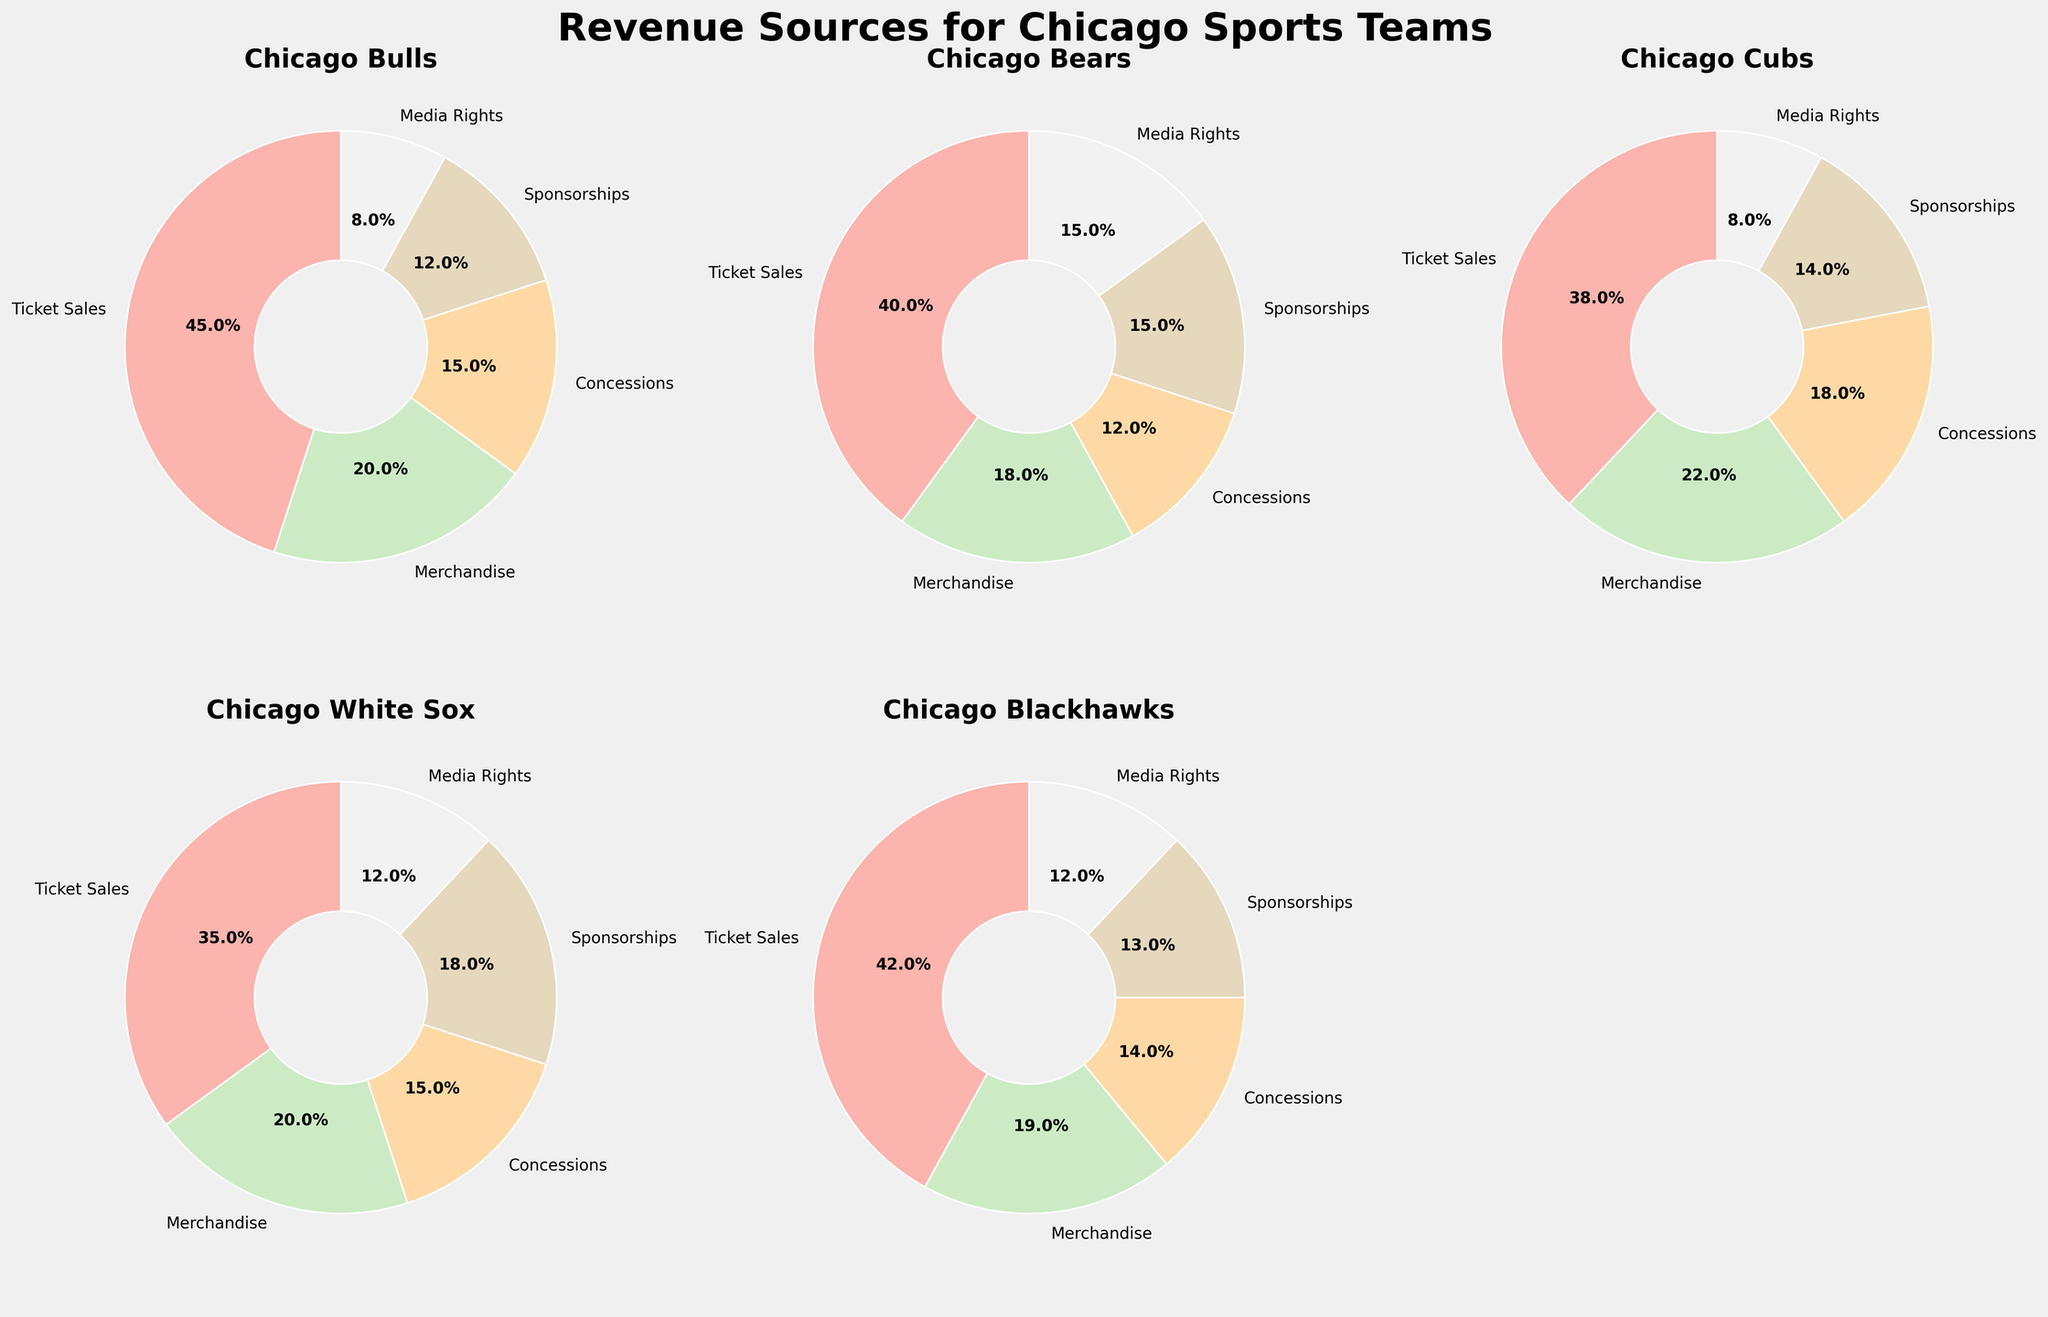What's the main revenue source for the Chicago Bulls? The pie chart for the Chicago Bulls shows that the largest segment is 'Ticket Sales' with the percentage of 45%.
Answer: Ticket Sales Which team has the lowest percentage of Media Rights revenue, and what is that percentage? By comparing the Media Rights segments in each team’s pie chart, you can see that both the Chicago Bulls and Chicago Cubs have the lowest Media Rights percentage at 8%.
Answer: Chicago Bulls and Chicago Cubs, 8% What is the combined percentage of Merchandise and Concessions revenue for the Chicago White Sox? The Merchandise segment is 20% and the Concessions segment is 15%. Adding these together gives 20% + 15% = 35%.
Answer: 35% Which team's sponsorship revenue is higher, the Chicago Bears or the Chicago Blackhawks, and by what percentage? The Chicago Bears have a Sponsorships percentage of 15%, and the Chicago Blackhawks have 13%. The difference is 15% - 13% = 2%.
Answer: Chicago Bears, 2% Among all teams, which one has the highest percentage of Merchandise revenue? By examining each team's pie chart, you see that the Chicago Cubs have the highest Merchandise revenue percentage at 22%.
Answer: Chicago Cubs What is the average percentage for Concessions revenue across all teams? The Concessions percentages are: Bulls 15%, Bears 12%, Cubs 18%, White Sox 15%, Blackhawks 14%. Adding them gives 15 + 12 + 18 + 15 + 14 = 74. The average is 74/5 = 14.8%.
Answer: 14.8% How do the Ticket Sales percentages for the Chicago Bulls and Chicago Bears compare? The Chicago Bulls' Ticket Sales percentage is 45%, and the Chicago Bears' is 40%. Bulls' Ticket Sales percentage is higher by 45% - 40% = 5%.
Answer: Chicago Bulls, 5% Which team relies the most on Ticket Sales for their revenue? By looking at the largest slices across all pie charts, the Chicago Bulls have the highest percentage for Ticket Sales at 45%.
Answer: Chicago Bulls What is the difference between the Sponsorships and Media Rights percentage for the Chicago White Sox? The Sponsorships percentage for the White Sox is 18%, and the Media Rights percentage is 12%. The difference is 18% - 12% = 6%.
Answer: 6% Which team has the smallest difference between their Ticket Sales and Merchandise revenue percentages, and what is that difference? By calculating the differences: Bulls 45%-20%=25%, Bears 40%-18%=22%, Cubs 38%-22%=16%, White Sox 35%-20%=15%, Blackhawks 42%-19%=23%. The smallest difference is for the White Sox with 15%.
Answer: Chicago White Sox, 15% 